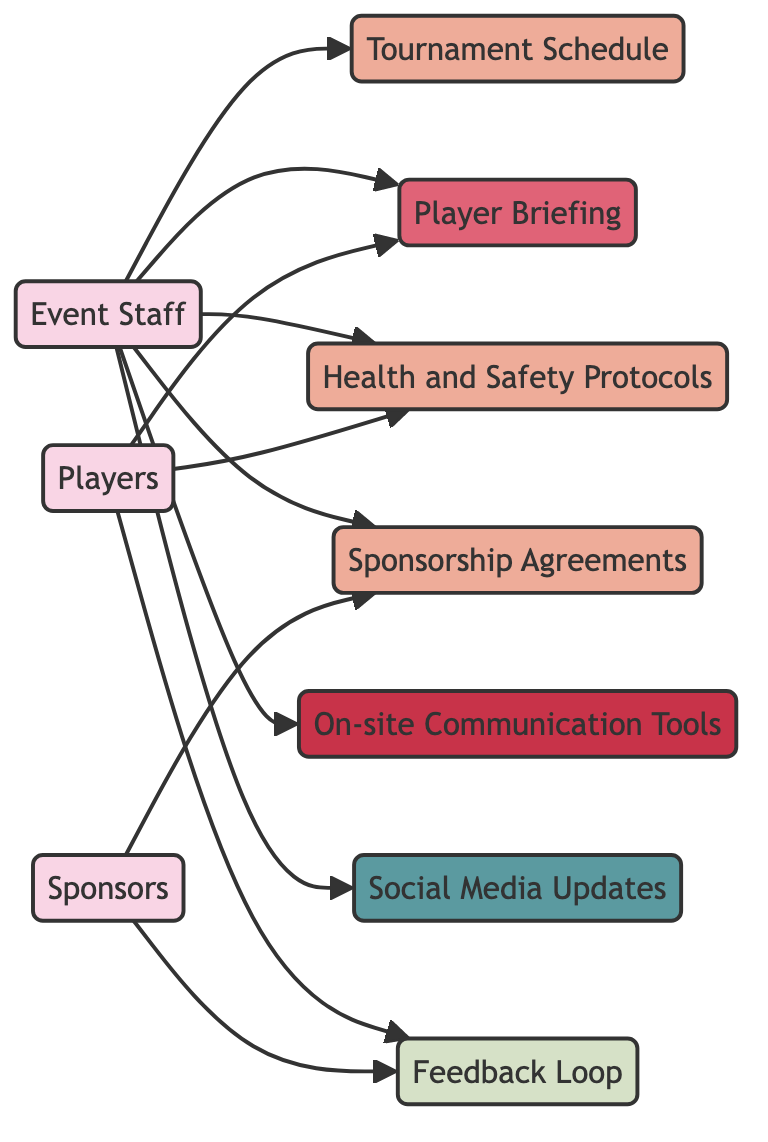What entities are represented in the diagram? The diagram contains three entities: Event Staff, Players, and Sponsors. These are indicated by the nodes categorized as 'Entity'.
Answer: Event Staff, Players, Sponsors How many edges connect the Event Staff to other nodes? By counting the edges originating from the Event Staff node, we find there are five connections: to Tournament Schedule, Player Briefing, Health and Safety Protocols, Sponsorship Agreements, On-site Communication Tools, and Social Media Updates.
Answer: 5 What document is linked to Players? Players are linked to two documents: Player Briefing and Health and Safety Protocols. By examining the edges originating from the Players node, we can infer the documents directly associated with them.
Answer: Player Briefing, Health and Safety Protocols Which entity is associated with Feedback Loop? Both Players and Sponsors are associated with the Feedback Loop, as the edges show connections from both entities to this process.
Answer: Players, Sponsors What tool does Event Staff use for communication? The On-site Communication Tools node is directly connected to the Event Staff, indicating the tool used by them for communication purposes.
Answer: On-site Communication Tools How many total nodes are there in the diagram? By counting all the distinct nodes, we find there are ten in total: three entities, four documents, one event, one tool, one channel, and one process.
Answer: 10 What type of channel is used for communication updates? Social Media Updates are the designated communication channel for updates, as shown by the node specifically categorized as 'Channel'.
Answer: Social Media Updates What is the relationship between Event Staff and Sponsorship Agreements? The Event Staff is responsible for managing Sponsorship Agreements, as indicated by the directed edge from Event Staff to this document.
Answer: Responsible for managing What is the main purpose of the Player Briefing? The Player Briefing is an event that involves interaction with the Players regarding important pre-tournament details, as indicated by the connection between Players and this event node.
Answer: Interaction regarding important details 